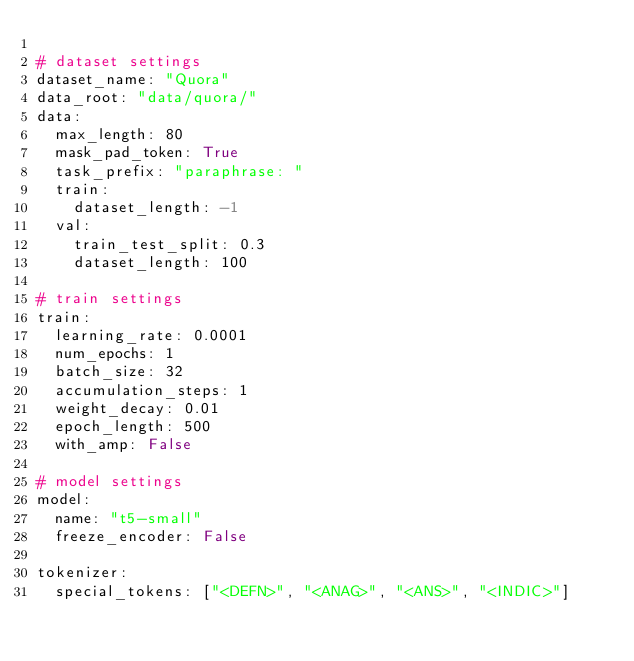Convert code to text. <code><loc_0><loc_0><loc_500><loc_500><_YAML_>
# dataset settings
dataset_name: "Quora"
data_root: "data/quora/"
data:
  max_length: 80
  mask_pad_token: True
  task_prefix: "paraphrase: "
  train:
    dataset_length: -1
  val:
    train_test_split: 0.3
    dataset_length: 100

# train settings
train:
  learning_rate: 0.0001
  num_epochs: 1
  batch_size: 32
  accumulation_steps: 1
  weight_decay: 0.01
  epoch_length: 500
  with_amp: False

# model settings
model:
  name: "t5-small"
  freeze_encoder: False

tokenizer:
  special_tokens: ["<DEFN>", "<ANAG>", "<ANS>", "<INDIC>"]
</code> 